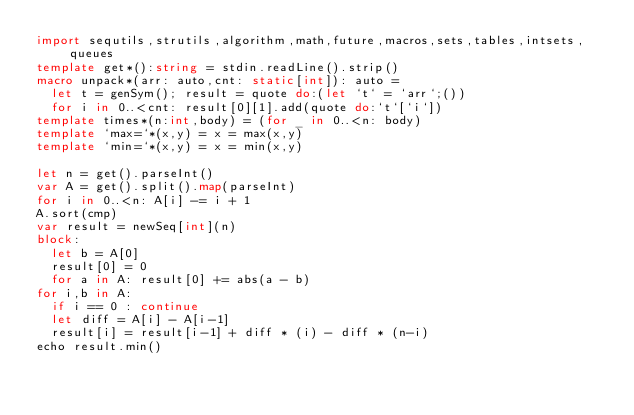<code> <loc_0><loc_0><loc_500><loc_500><_Nim_>import sequtils,strutils,algorithm,math,future,macros,sets,tables,intsets,queues
template get*():string = stdin.readLine().strip()
macro unpack*(arr: auto,cnt: static[int]): auto =
  let t = genSym(); result = quote do:(let `t` = `arr`;())
  for i in 0..<cnt: result[0][1].add(quote do:`t`[`i`])
template times*(n:int,body) = (for _ in 0..<n: body)
template `max=`*(x,y) = x = max(x,y)
template `min=`*(x,y) = x = min(x,y)

let n = get().parseInt()
var A = get().split().map(parseInt)
for i in 0..<n: A[i] -= i + 1
A.sort(cmp)
var result = newSeq[int](n)
block:
  let b = A[0]
  result[0] = 0
  for a in A: result[0] += abs(a - b)
for i,b in A:
  if i == 0 : continue
  let diff = A[i] - A[i-1]
  result[i] = result[i-1] + diff * (i) - diff * (n-i)
echo result.min()


</code> 